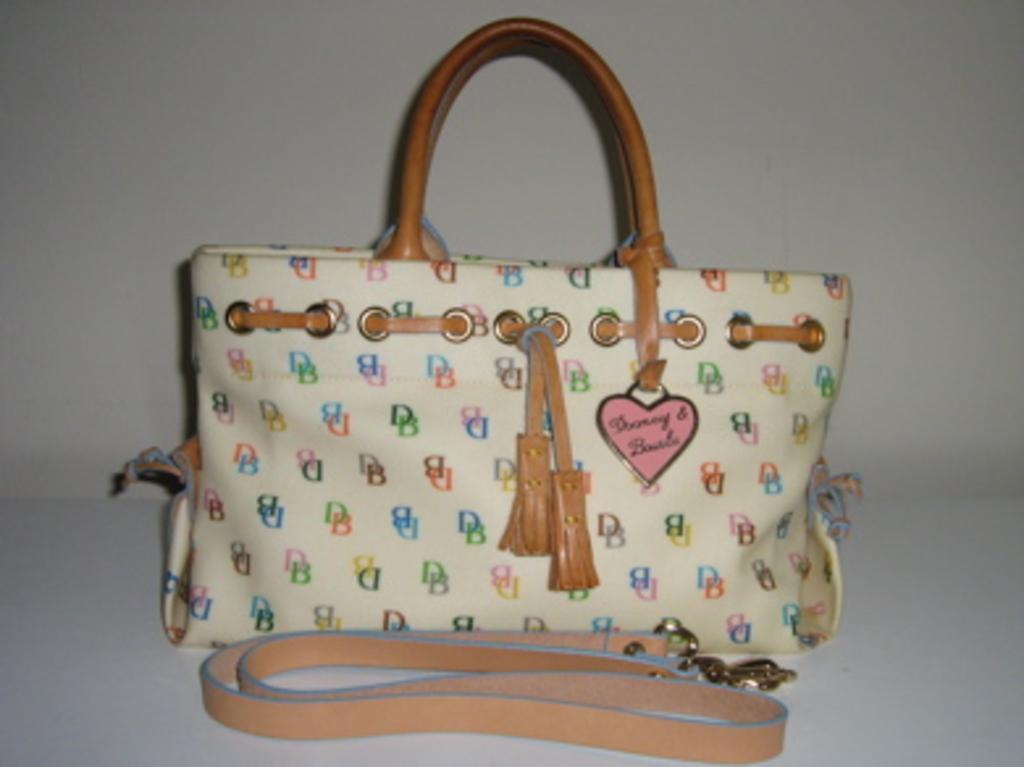Please provide a concise description of this image. Here we can see a handbag which have heart symbol on it 